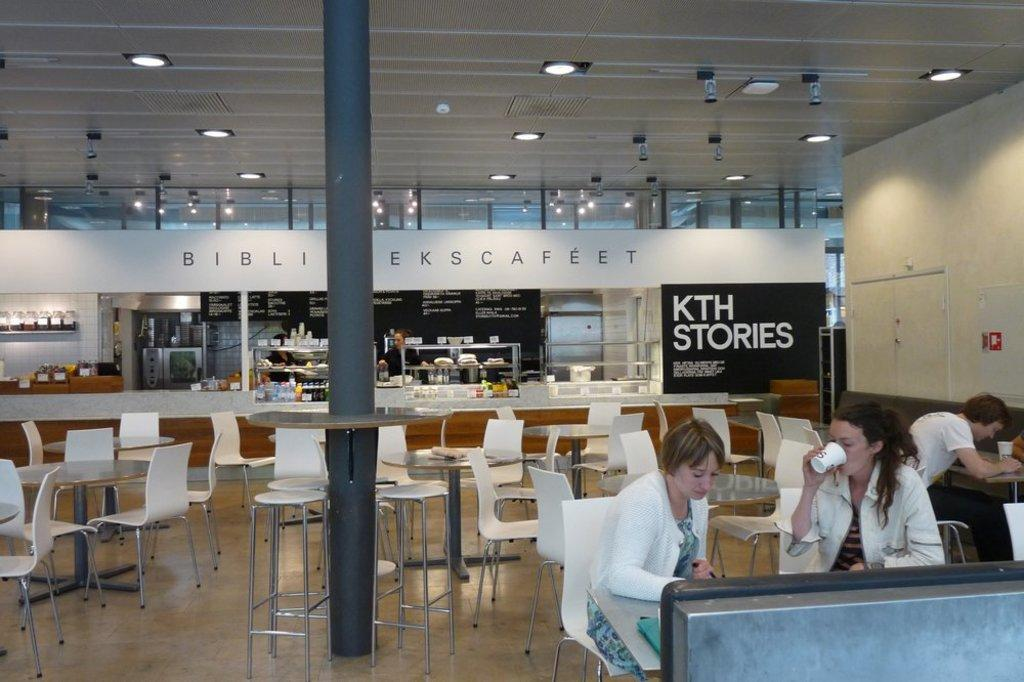What type of space is shown in the image? The image depicts a big room. What furniture is present in the room? The room contains chairs and tables. Are there any decorations or additional items in the room? Yes, there are bottles and posters in the room. What is the activity of the people in the room? Some people are sitting on chairs in the room, and they are doing something. What type of tank can be seen in the room? There is no tank present in the room; the image only shows a big room with chairs, tables, bottles, posters, and people. Are there any bushes in the room? No, there are no bushes in the room; the image depicts an indoor setting with furniture and decorations. 